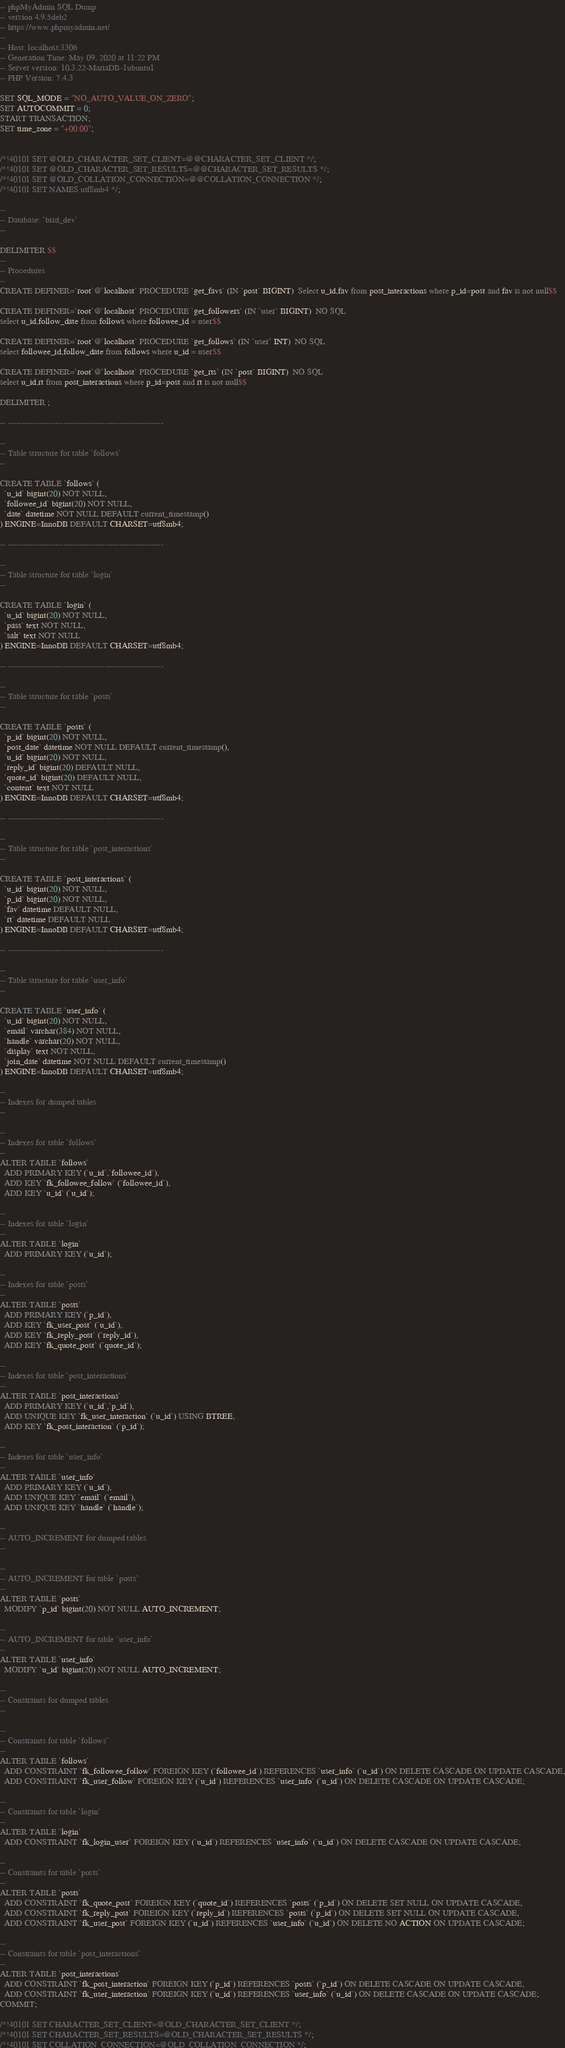<code> <loc_0><loc_0><loc_500><loc_500><_SQL_>-- phpMyAdmin SQL Dump
-- version 4.9.5deb2
-- https://www.phpmyadmin.net/
--
-- Host: localhost:3306
-- Generation Time: May 09, 2020 at 11:22 PM
-- Server version: 10.3.22-MariaDB-1ubuntu1
-- PHP Version: 7.4.3

SET SQL_MODE = "NO_AUTO_VALUE_ON_ZERO";
SET AUTOCOMMIT = 0;
START TRANSACTION;
SET time_zone = "+00:00";


/*!40101 SET @OLD_CHARACTER_SET_CLIENT=@@CHARACTER_SET_CLIENT */;
/*!40101 SET @OLD_CHARACTER_SET_RESULTS=@@CHARACTER_SET_RESULTS */;
/*!40101 SET @OLD_COLLATION_CONNECTION=@@COLLATION_CONNECTION */;
/*!40101 SET NAMES utf8mb4 */;

--
-- Database: `bird_dev`
--

DELIMITER $$
--
-- Procedures
--
CREATE DEFINER=`root`@`localhost` PROCEDURE `get_favs` (IN `post` BIGINT)  Select u_id,fav from post_interactions where p_id=post and fav is not null$$

CREATE DEFINER=`root`@`localhost` PROCEDURE `get_followers` (IN `user` BIGINT)  NO SQL
select u_id,follow_date from follows where followee_id = user$$

CREATE DEFINER=`root`@`localhost` PROCEDURE `get_follows` (IN `user` INT)  NO SQL
select followee_id,follow_date from follows where u_id = user$$

CREATE DEFINER=`root`@`localhost` PROCEDURE `get_rts` (IN `post` BIGINT)  NO SQL
select u_id,rt from post_interactions where p_id=post and rt is not null$$

DELIMITER ;

-- --------------------------------------------------------

--
-- Table structure for table `follows`
--

CREATE TABLE `follows` (
  `u_id` bigint(20) NOT NULL,
  `followee_id` bigint(20) NOT NULL,
  `date` datetime NOT NULL DEFAULT current_timestamp()
) ENGINE=InnoDB DEFAULT CHARSET=utf8mb4;

-- --------------------------------------------------------

--
-- Table structure for table `login`
--

CREATE TABLE `login` (
  `u_id` bigint(20) NOT NULL,
  `pass` text NOT NULL,
  `salt` text NOT NULL
) ENGINE=InnoDB DEFAULT CHARSET=utf8mb4;

-- --------------------------------------------------------

--
-- Table structure for table `posts`
--

CREATE TABLE `posts` (
  `p_id` bigint(20) NOT NULL,
  `post_date` datetime NOT NULL DEFAULT current_timestamp(),
  `u_id` bigint(20) NOT NULL,
  `reply_id` bigint(20) DEFAULT NULL,
  `quote_id` bigint(20) DEFAULT NULL,
  `content` text NOT NULL
) ENGINE=InnoDB DEFAULT CHARSET=utf8mb4;

-- --------------------------------------------------------

--
-- Table structure for table `post_interactions`
--

CREATE TABLE `post_interactions` (
  `u_id` bigint(20) NOT NULL,
  `p_id` bigint(20) NOT NULL,
  `fav` datetime DEFAULT NULL,
  `rt` datetime DEFAULT NULL
) ENGINE=InnoDB DEFAULT CHARSET=utf8mb4;

-- --------------------------------------------------------

--
-- Table structure for table `user_info`
--

CREATE TABLE `user_info` (
  `u_id` bigint(20) NOT NULL,
  `email` varchar(384) NOT NULL,
  `handle` varchar(20) NOT NULL,
  `display` text NOT NULL,
  `join_date` datetime NOT NULL DEFAULT current_timestamp()
) ENGINE=InnoDB DEFAULT CHARSET=utf8mb4;

--
-- Indexes for dumped tables
--

--
-- Indexes for table `follows`
--
ALTER TABLE `follows`
  ADD PRIMARY KEY (`u_id`,`followee_id`),
  ADD KEY `fk_followee_follow` (`followee_id`),
  ADD KEY `u_id` (`u_id`);

--
-- Indexes for table `login`
--
ALTER TABLE `login`
  ADD PRIMARY KEY (`u_id`);

--
-- Indexes for table `posts`
--
ALTER TABLE `posts`
  ADD PRIMARY KEY (`p_id`),
  ADD KEY `fk_user_post` (`u_id`),
  ADD KEY `fk_reply_post` (`reply_id`),
  ADD KEY `fk_quote_post` (`quote_id`);

--
-- Indexes for table `post_interactions`
--
ALTER TABLE `post_interactions`
  ADD PRIMARY KEY (`u_id`,`p_id`),
  ADD UNIQUE KEY `fk_user_interaction` (`u_id`) USING BTREE,
  ADD KEY `fk_post_interaction` (`p_id`);

--
-- Indexes for table `user_info`
--
ALTER TABLE `user_info`
  ADD PRIMARY KEY (`u_id`),
  ADD UNIQUE KEY `email` (`email`),
  ADD UNIQUE KEY `handle` (`handle`);

--
-- AUTO_INCREMENT for dumped tables
--

--
-- AUTO_INCREMENT for table `posts`
--
ALTER TABLE `posts`
  MODIFY `p_id` bigint(20) NOT NULL AUTO_INCREMENT;

--
-- AUTO_INCREMENT for table `user_info`
--
ALTER TABLE `user_info`
  MODIFY `u_id` bigint(20) NOT NULL AUTO_INCREMENT;

--
-- Constraints for dumped tables
--

--
-- Constraints for table `follows`
--
ALTER TABLE `follows`
  ADD CONSTRAINT `fk_followee_follow` FOREIGN KEY (`followee_id`) REFERENCES `user_info` (`u_id`) ON DELETE CASCADE ON UPDATE CASCADE,
  ADD CONSTRAINT `fk_user_follow` FOREIGN KEY (`u_id`) REFERENCES `user_info` (`u_id`) ON DELETE CASCADE ON UPDATE CASCADE;

--
-- Constraints for table `login`
--
ALTER TABLE `login`
  ADD CONSTRAINT `fk_login_user` FOREIGN KEY (`u_id`) REFERENCES `user_info` (`u_id`) ON DELETE CASCADE ON UPDATE CASCADE;

--
-- Constraints for table `posts`
--
ALTER TABLE `posts`
  ADD CONSTRAINT `fk_quote_post` FOREIGN KEY (`quote_id`) REFERENCES `posts` (`p_id`) ON DELETE SET NULL ON UPDATE CASCADE,
  ADD CONSTRAINT `fk_reply_post` FOREIGN KEY (`reply_id`) REFERENCES `posts` (`p_id`) ON DELETE SET NULL ON UPDATE CASCADE,
  ADD CONSTRAINT `fk_user_post` FOREIGN KEY (`u_id`) REFERENCES `user_info` (`u_id`) ON DELETE NO ACTION ON UPDATE CASCADE;

--
-- Constraints for table `post_interactions`
--
ALTER TABLE `post_interactions`
  ADD CONSTRAINT `fk_post_interaction` FOREIGN KEY (`p_id`) REFERENCES `posts` (`p_id`) ON DELETE CASCADE ON UPDATE CASCADE,
  ADD CONSTRAINT `fk_user_interaction` FOREIGN KEY (`u_id`) REFERENCES `user_info` (`u_id`) ON DELETE CASCADE ON UPDATE CASCADE;
COMMIT;

/*!40101 SET CHARACTER_SET_CLIENT=@OLD_CHARACTER_SET_CLIENT */;
/*!40101 SET CHARACTER_SET_RESULTS=@OLD_CHARACTER_SET_RESULTS */;
/*!40101 SET COLLATION_CONNECTION=@OLD_COLLATION_CONNECTION */;
</code> 